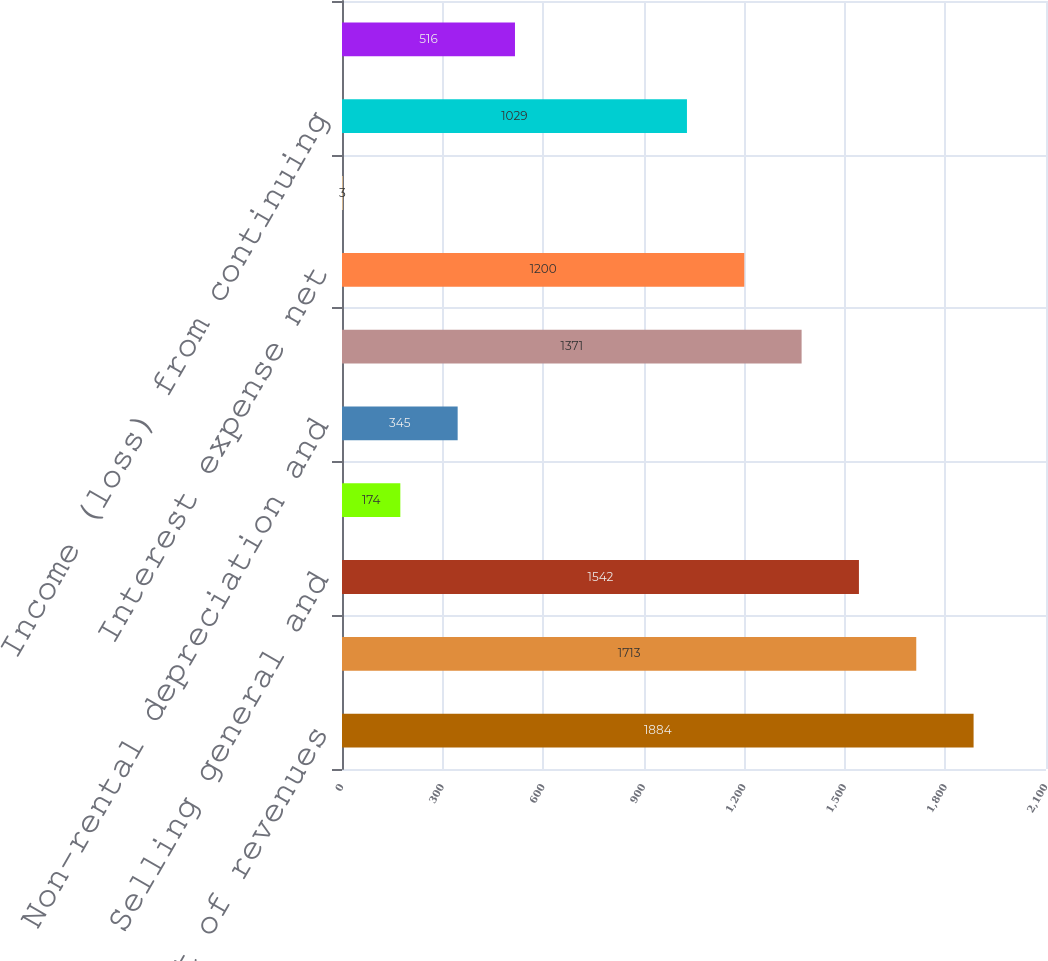Convert chart to OTSL. <chart><loc_0><loc_0><loc_500><loc_500><bar_chart><fcel>Total cost of revenues<fcel>Gross profit<fcel>Selling general and<fcel>Restructuring charge<fcel>Non-rental depreciation and<fcel>Operating income<fcel>Interest expense net<fcel>Other income net<fcel>Income (loss) from continuing<fcel>Provision (benefit) for income<nl><fcel>1884<fcel>1713<fcel>1542<fcel>174<fcel>345<fcel>1371<fcel>1200<fcel>3<fcel>1029<fcel>516<nl></chart> 